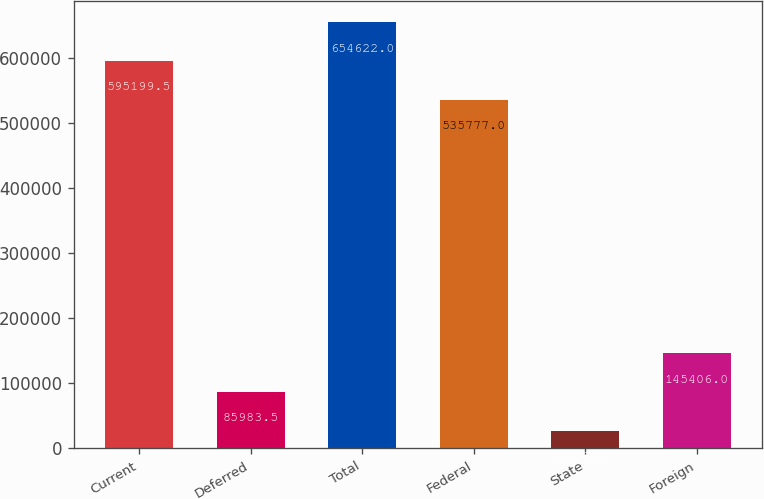Convert chart. <chart><loc_0><loc_0><loc_500><loc_500><bar_chart><fcel>Current<fcel>Deferred<fcel>Total<fcel>Federal<fcel>State<fcel>Foreign<nl><fcel>595200<fcel>85983.5<fcel>654622<fcel>535777<fcel>26561<fcel>145406<nl></chart> 